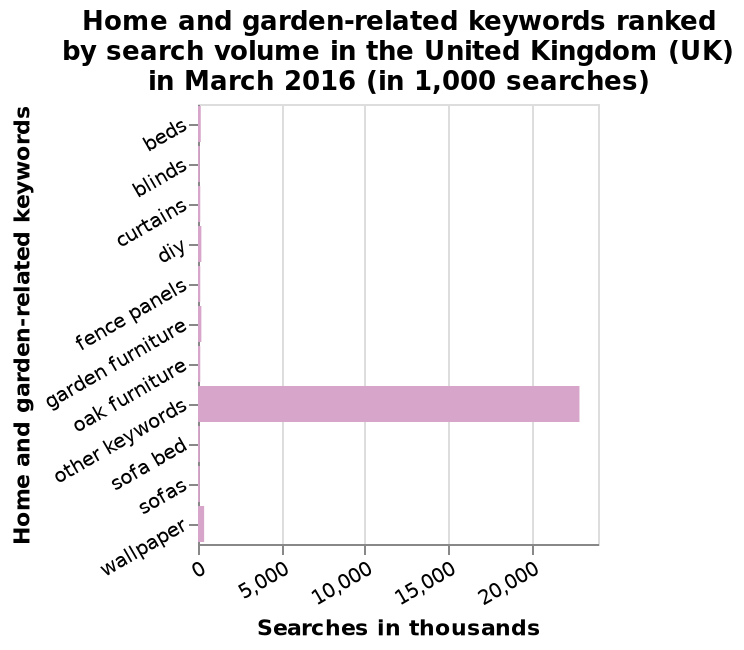<image>
What is the range of the x-axis on the bar plot?  The range of the x-axis on the bar plot is from 0 to 20,000, in thousands. What was the highest number of searches for any keyword? The highest number of searches was just under 25,000 for other keywords. What does the y-axis measure on the bar plot?  The y-axis measures the "Search volume" of home and garden-related keywords in the United Kingdom in March 2016, in thousands of searches. 